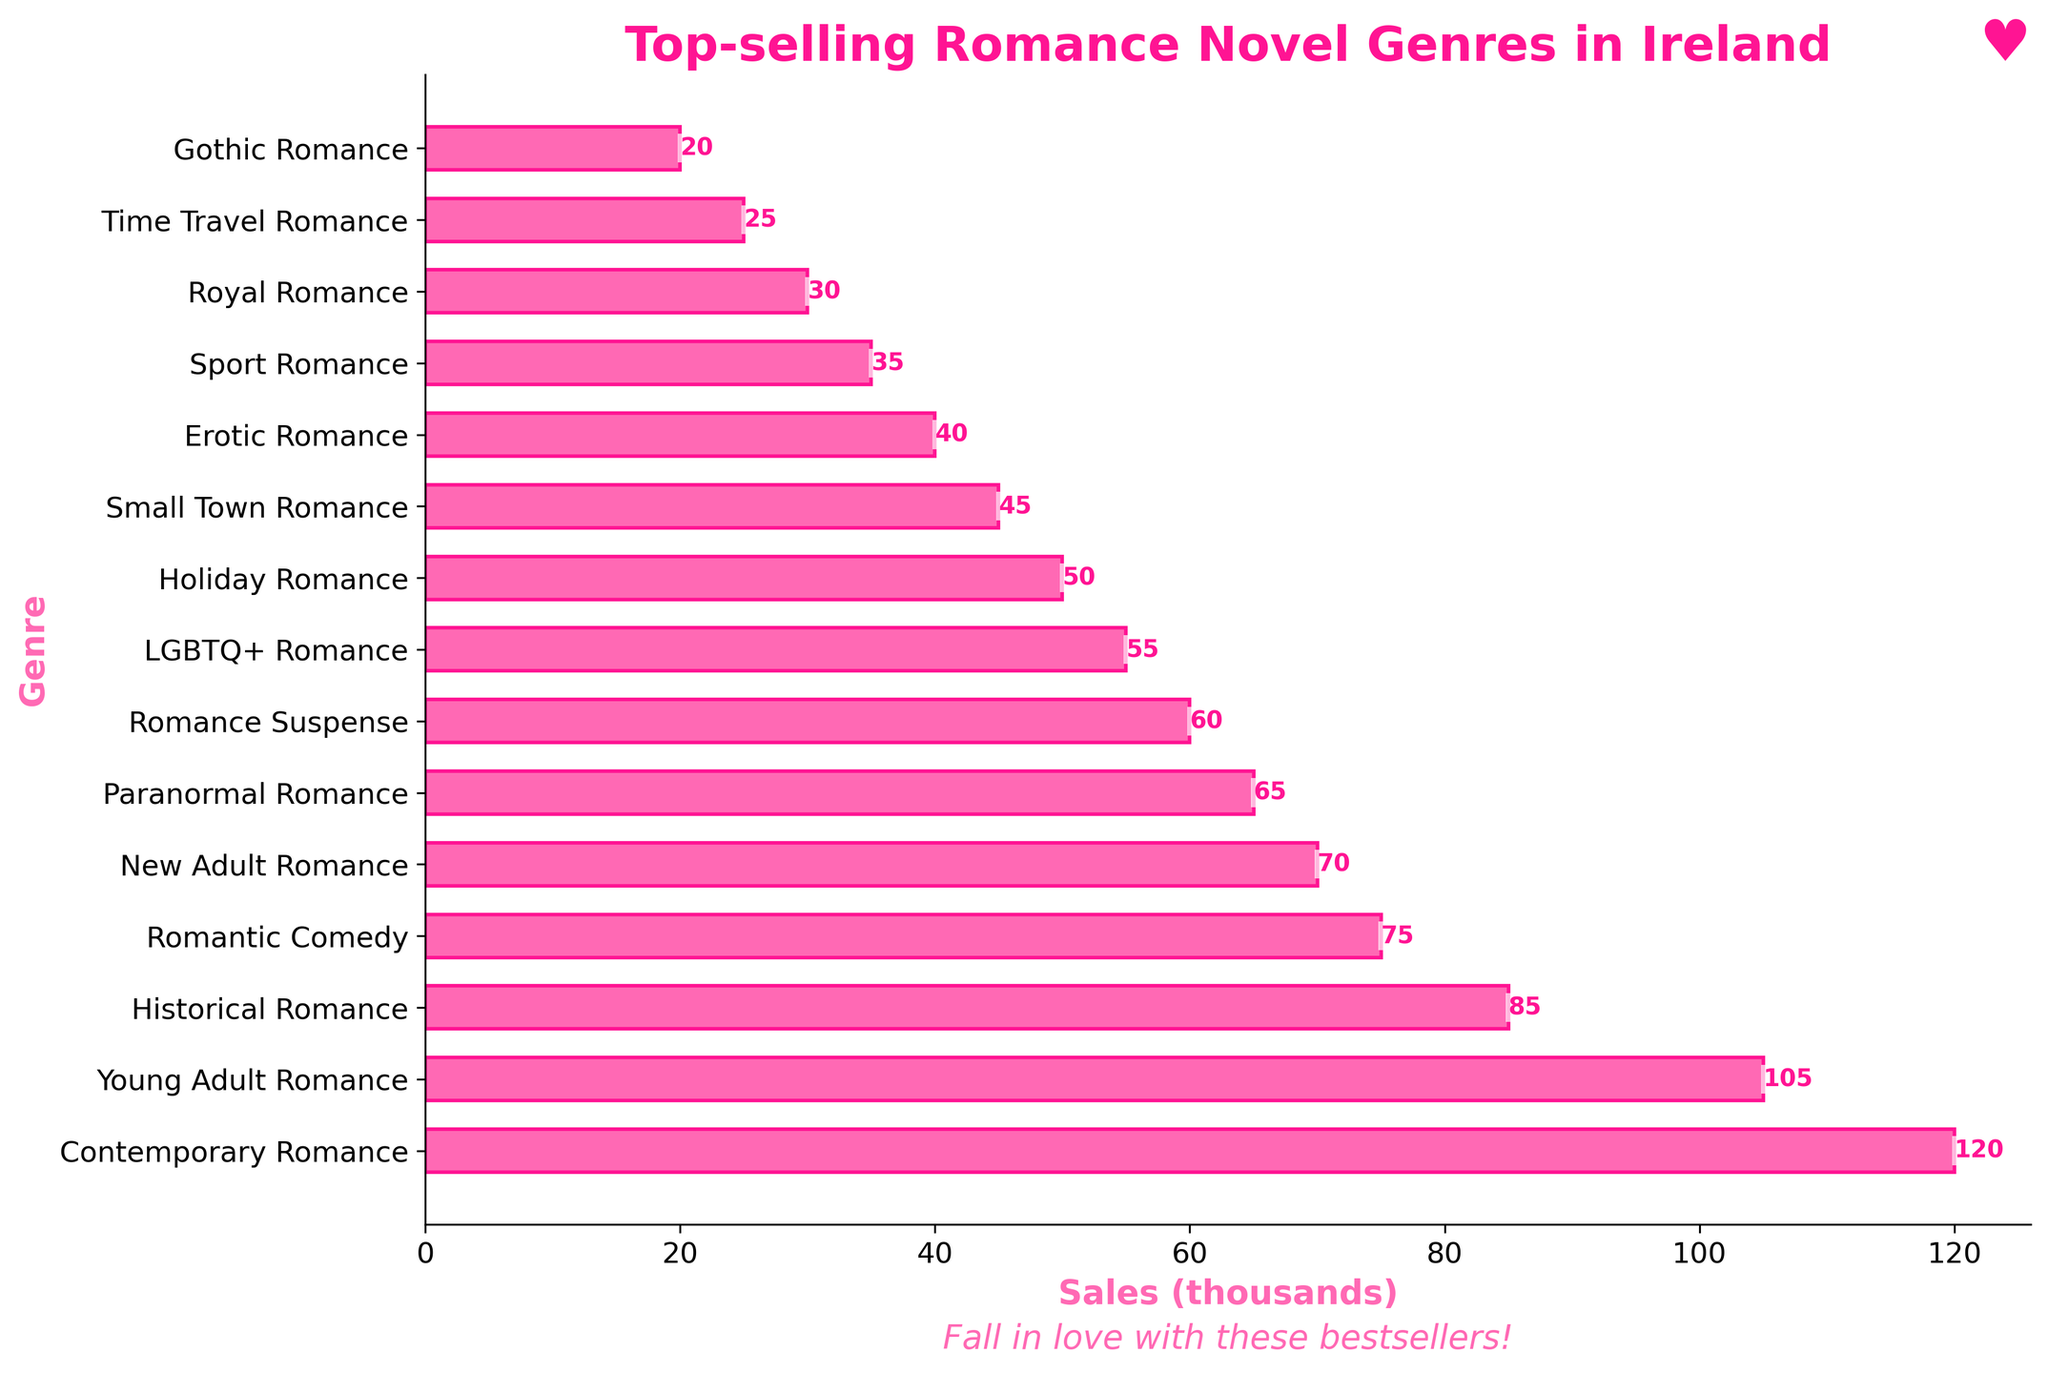Which genre has the highest sales? The genre with the longest bar represents the highest sales. In this chart, the Contemporary Romance bar is the longest.
Answer: Contemporary Romance What is the difference in sales between Contemporary Romance and Holiday Romance? Subtract the sales of Holiday Romance from the sales of Contemporary Romance. Contemporary Romance has sales of 120,000 and Holiday Romance has sales of 50,000: 120,000 - 50,000 = 70,000.
Answer: 70,000 Which genres have sales greater than 100,000? Identify the genres with bars extending beyond the 100,000 mark on the x-axis. Contemporary Romance and Young Adult Romance both have sales greater than 100,000.
Answer: Contemporary Romance, Young Adult Romance How many genres have sales between 30,000 and 70,000? Identify the bars whose sales fall within the range of 30,000 to 70,000. These genres are New Adult Romance, Paranormal Romance, Romance Suspense, LGBTQ+ Romance, Holiday Romance, Small Town Romance, and Erotic Romance.
Answer: 7 Are there any genres with sales equal to 50,000? Look for a bar that ends exactly at the 50,000 mark. Holiday Romance is the genre with sales equal to 50,000.
Answer: Yes, Holiday Romance What's the total number of sales for the top three genres? Add the sales numbers of Contemporary Romance, Young Adult Romance, and Historical Romance: 120,000 (Contemporary Romance) + 105,000 (Young Adult Romance) + 85,000 (Historical Romance) = 310,000.
Answer: 310,000 Which genres have the least sales? Find the bar that represents the smallest value. Gothic Romance has the shortest bar, signifying the least sales.
Answer: Gothic Romance How do the sales of Romantic Comedy compare to Sport Romance? Compare the bar lengths of Romantic Comedy and Sport Romance. Romantic Comedy has a bar representing sales of 75,000, while Sport Romance has a bar indicating sales of 35,000. Therefore, Romantic Comedy has higher sales.
Answer: Romantic Comedy What's the combined sales for genres starting with the letter 'R'? Add the sales numbers of Romantic Comedy, Romance Suspense, and Royal Romance: 75,000 (Romantic Comedy) + 60,000 (Romance Suspense) + 30,000 (Royal Romance) = 165,000.
Answer: 165,000 What is the average sales of the bottom five genres? Add the sales numbers of the bottom five genres and then divide by five: (35,000 + 30,000 + 25,000 + 20,000) / 5 = 30,000.
Answer: 30,000 